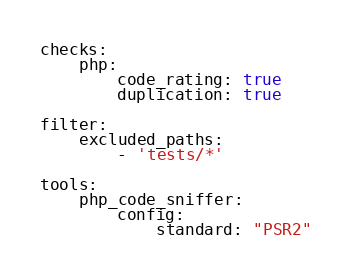Convert code to text. <code><loc_0><loc_0><loc_500><loc_500><_YAML_>checks:
    php:
        code_rating: true
        duplication: true

filter:
    excluded_paths:
        - 'tests/*'

tools:
    php_code_sniffer:
        config:
            standard: "PSR2"
</code> 